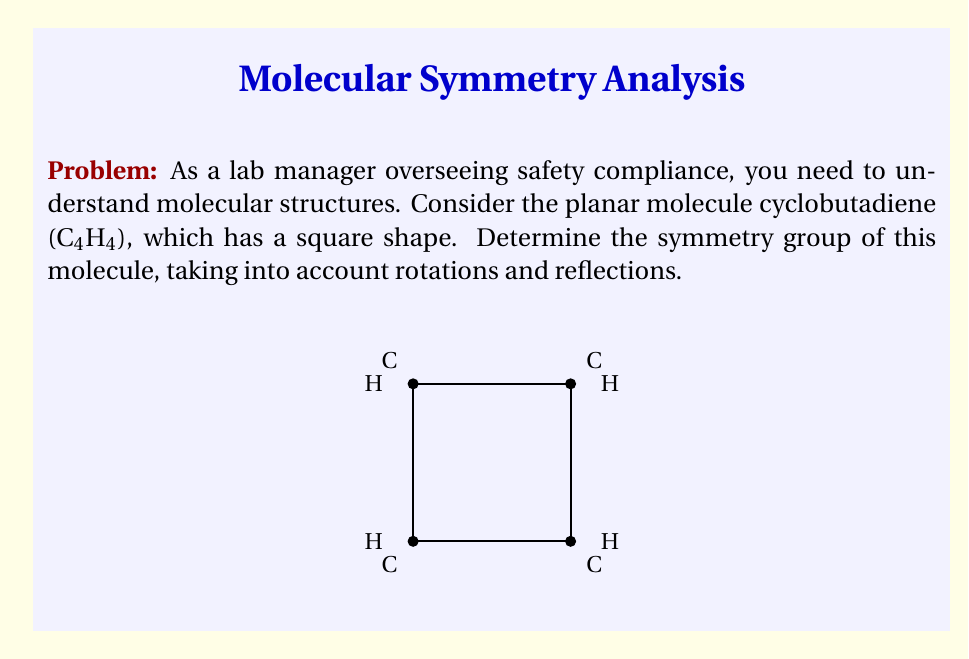What is the answer to this math problem? To determine the symmetry group of cyclobutadiene, we need to identify all symmetry operations that leave the molecule unchanged:

1) Rotations:
   - Identity (0° rotation): $E$
   - 90° rotation (clockwise and counterclockwise): $C_4$ and $C_4^3$
   - 180° rotation: $C_2$

2) Reflections:
   - Two diagonal reflections: $\sigma_d$ and $\sigma_d'$
   - Two reflections through the midpoints of opposite sides: $\sigma_v$ and $\sigma_h$

3) Count the symmetry operations:
   4 rotations + 4 reflections = 8 total symmetry operations

4) Identify the group:
   This set of symmetry operations forms the dihedral group $D_4$, which is isomorphic to the symmetry group of a square.

5) Group structure:
   $D_4 = \{E, C_4, C_2, C_4^3, \sigma_v, \sigma_h, \sigma_d, \sigma_d'\}$

The order of the group is 8, and it includes rotations by multiples of 90° and reflections across four axes.
Answer: $D_4$ 